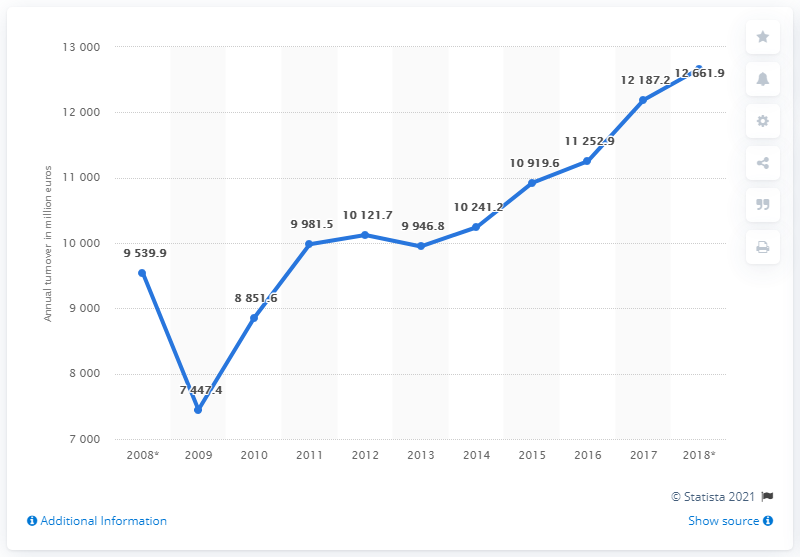Outline some significant characteristics in this image. The year with the downward peak is 2009. In 2017, the turnover of the Czech manufacturing of rubber and plastic products was 121,872.2 units. The increase from 2012 to 2018 is 2540.2. 